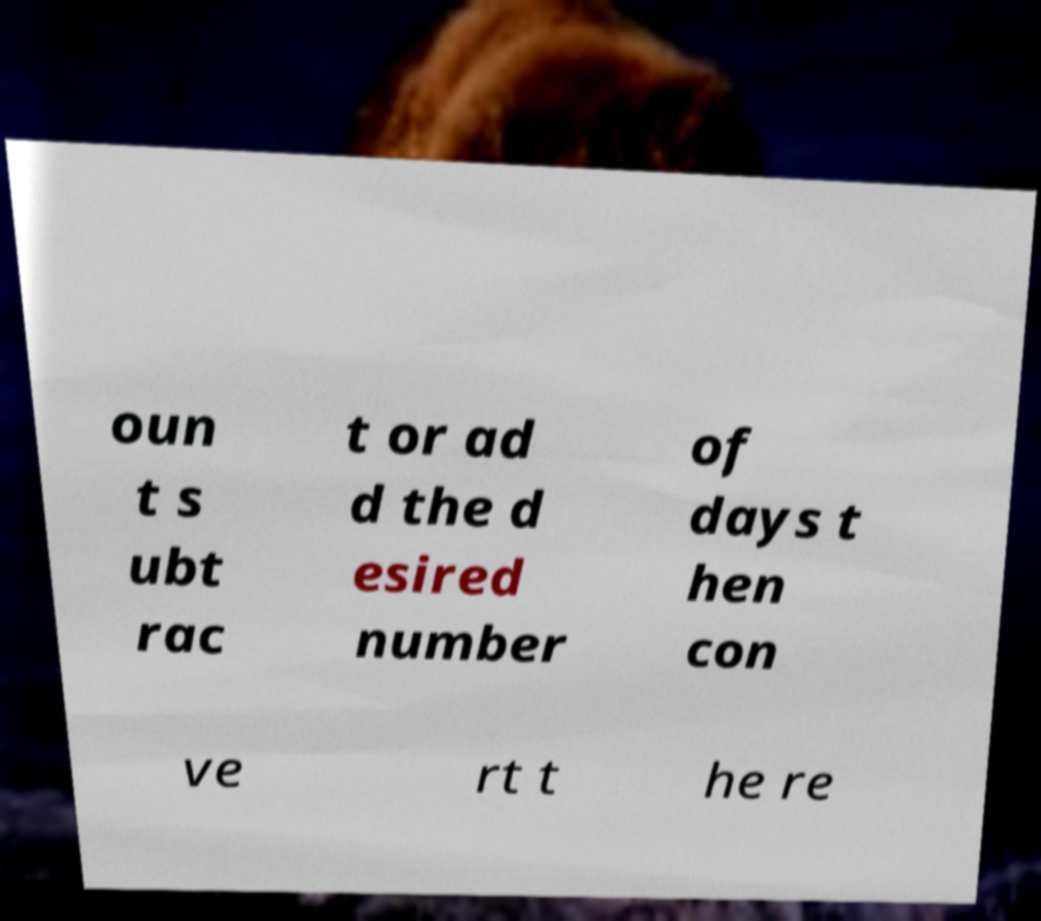There's text embedded in this image that I need extracted. Can you transcribe it verbatim? oun t s ubt rac t or ad d the d esired number of days t hen con ve rt t he re 